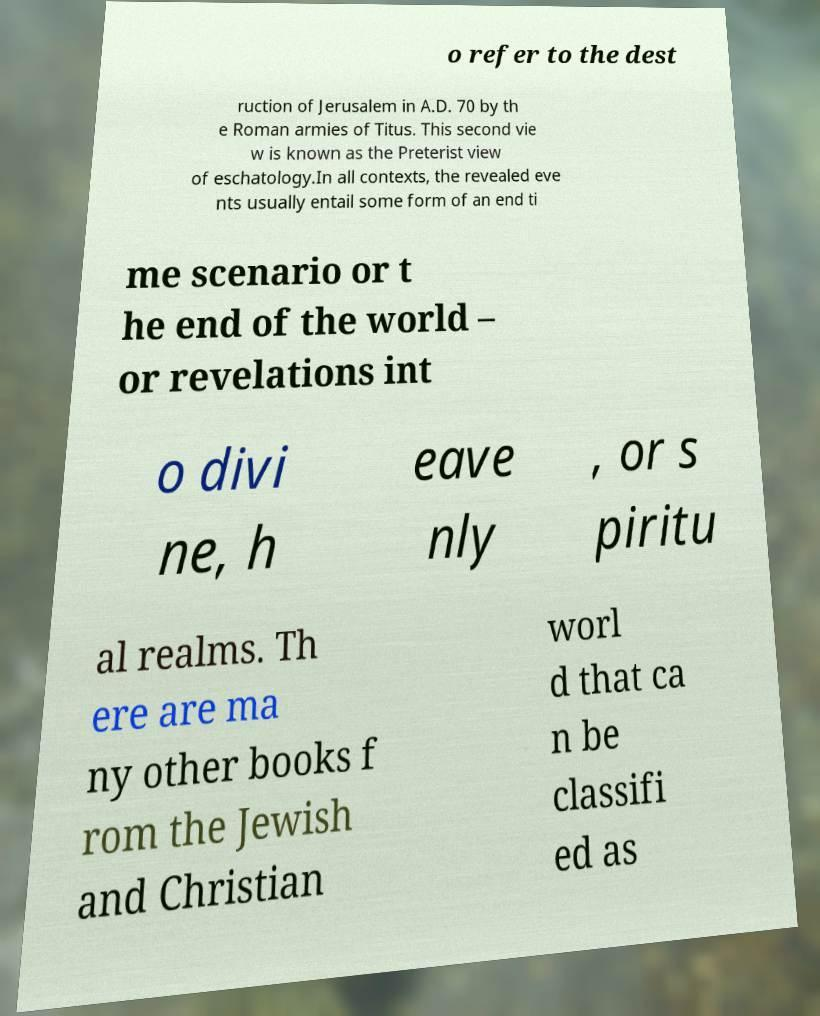Can you read and provide the text displayed in the image?This photo seems to have some interesting text. Can you extract and type it out for me? o refer to the dest ruction of Jerusalem in A.D. 70 by th e Roman armies of Titus. This second vie w is known as the Preterist view of eschatology.In all contexts, the revealed eve nts usually entail some form of an end ti me scenario or t he end of the world – or revelations int o divi ne, h eave nly , or s piritu al realms. Th ere are ma ny other books f rom the Jewish and Christian worl d that ca n be classifi ed as 